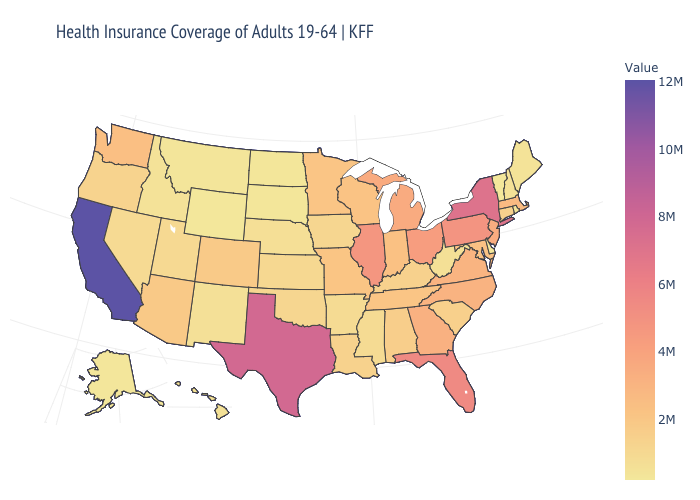Does Louisiana have a lower value than New York?
Be succinct. Yes. 